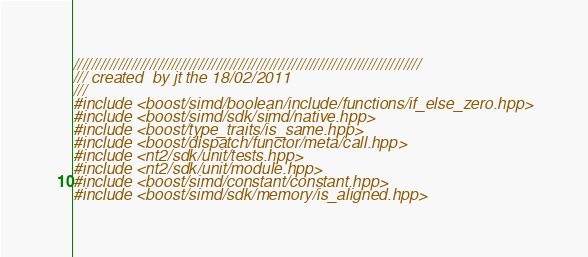Convert code to text. <code><loc_0><loc_0><loc_500><loc_500><_C++_>//////////////////////////////////////////////////////////////////////////////
/// created  by jt the 18/02/2011
///
#include <boost/simd/boolean/include/functions/if_else_zero.hpp>
#include <boost/simd/sdk/simd/native.hpp>
#include <boost/type_traits/is_same.hpp>
#include <boost/dispatch/functor/meta/call.hpp>
#include <nt2/sdk/unit/tests.hpp>
#include <nt2/sdk/unit/module.hpp>
#include <boost/simd/constant/constant.hpp>
#include <boost/simd/sdk/memory/is_aligned.hpp></code> 